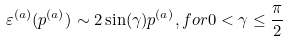Convert formula to latex. <formula><loc_0><loc_0><loc_500><loc_500>\varepsilon ^ { ( a ) } ( p ^ { ( a ) } ) \sim 2 \sin ( \gamma ) p ^ { ( a ) } , f o r 0 < \gamma \leq \frac { \pi } { 2 }</formula> 